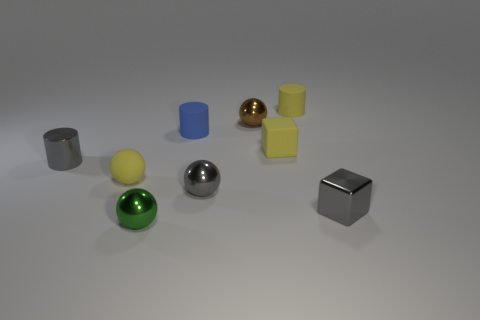Subtract all tiny yellow balls. How many balls are left? 3 Subtract all cylinders. How many objects are left? 6 Subtract all small metallic balls. Subtract all green metallic things. How many objects are left? 5 Add 2 tiny rubber blocks. How many tiny rubber blocks are left? 3 Add 2 tiny gray blocks. How many tiny gray blocks exist? 3 Subtract all brown spheres. How many spheres are left? 3 Subtract 0 purple cylinders. How many objects are left? 9 Subtract 1 balls. How many balls are left? 3 Subtract all brown spheres. Subtract all blue cubes. How many spheres are left? 3 